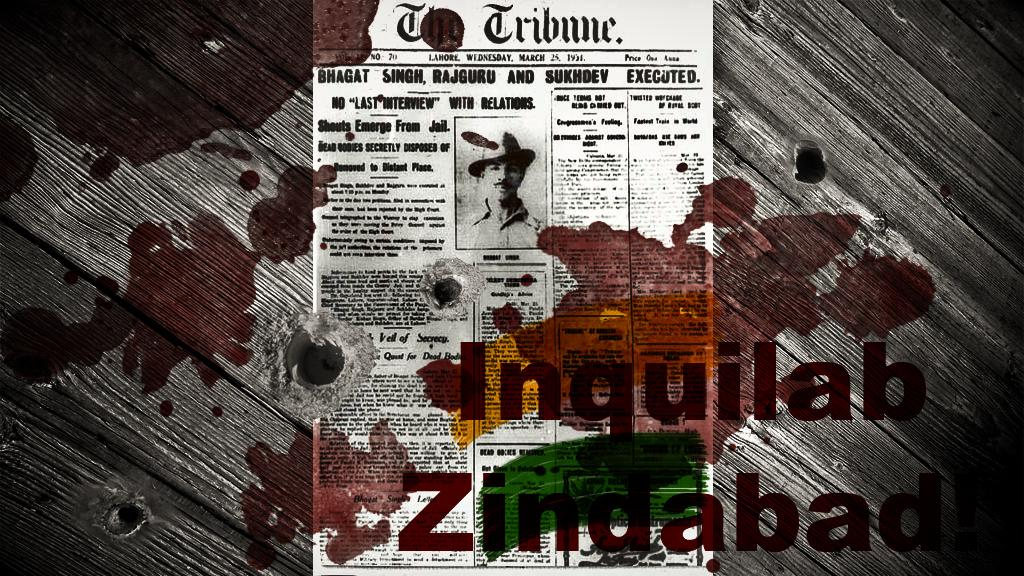<image>
Write a terse but informative summary of the picture. A copy of the newspaper the tribune is covered in red stains. 